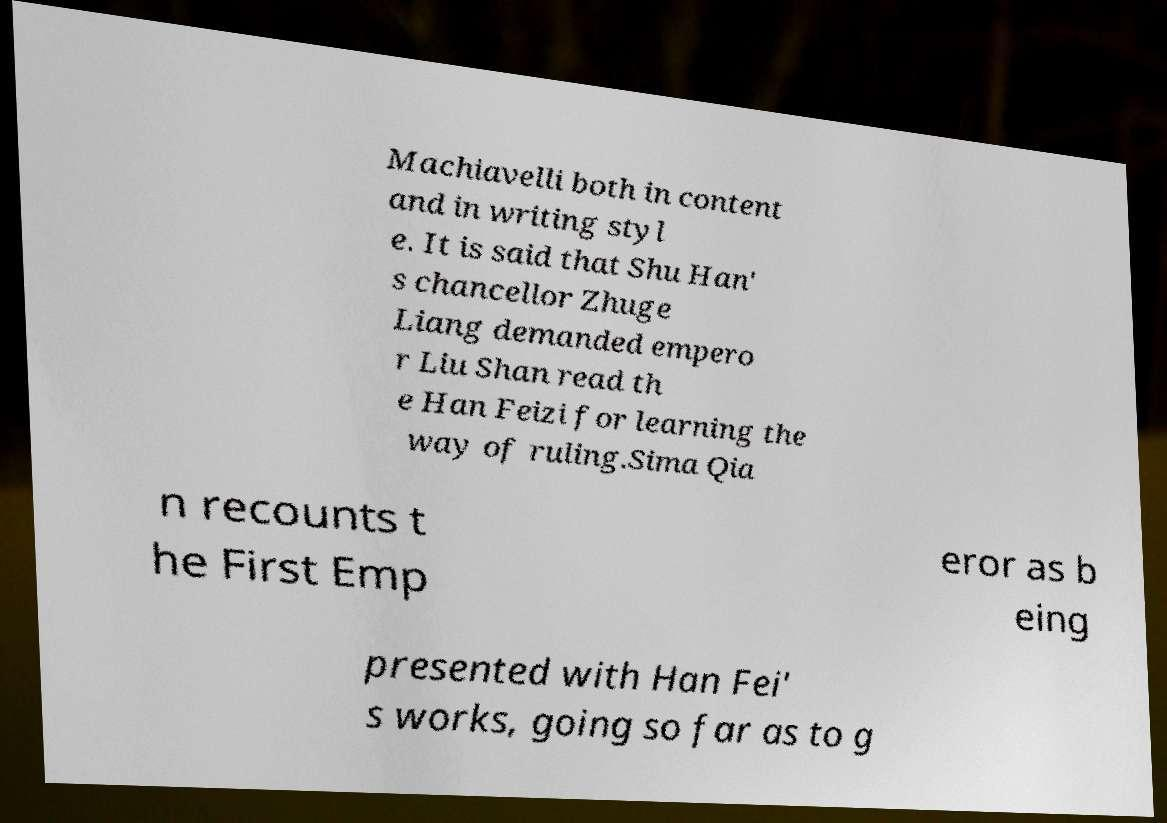For documentation purposes, I need the text within this image transcribed. Could you provide that? Machiavelli both in content and in writing styl e. It is said that Shu Han' s chancellor Zhuge Liang demanded empero r Liu Shan read th e Han Feizi for learning the way of ruling.Sima Qia n recounts t he First Emp eror as b eing presented with Han Fei' s works, going so far as to g 